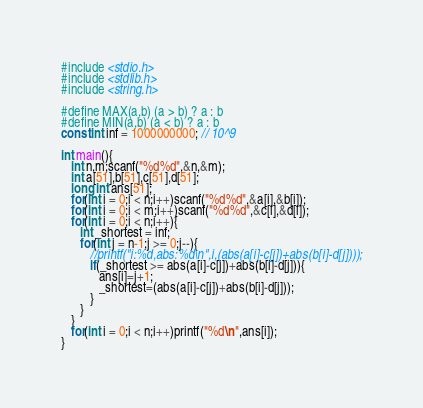<code> <loc_0><loc_0><loc_500><loc_500><_C_>#include <stdio.h>
#include <stdlib.h>
#include <string.h>

#define MAX(a,b) (a > b) ? a : b
#define MIN(a,b) (a < b) ? a : b
const int inf = 1000000000; // 10^9

int main(){
   int n,m;scanf("%d%d",&n,&m);
   int a[51],b[51],c[51],d[51];
   long int ans[51];
   for(int i = 0;i < n;i++)scanf("%d%d",&a[i],&b[i]);
   for(int i = 0;i < m;i++)scanf("%d%d",&c[i],&d[i]);
   for(int i = 0;i < n;i++){
      int _shortest = inf;
      for(int j = n-1;j >= 0;j--){
         //printf("i:%d,abs:%d\n",i,(abs(a[i]-c[j])+abs(b[i]-d[j])));
         if(_shortest >= abs(a[i]-c[j])+abs(b[i]-d[j])){
            ans[i]=j+1;
            _shortest=(abs(a[i]-c[j])+abs(b[i]-d[j]));
         }
      }
   }
   for(int i = 0;i < n;i++)printf("%d\n",ans[i]);
}</code> 